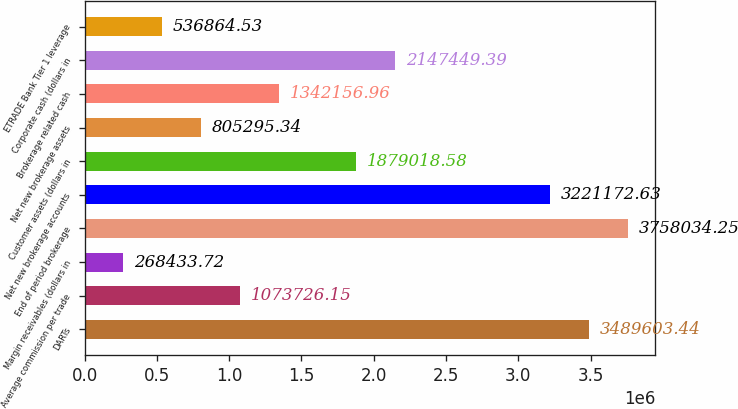<chart> <loc_0><loc_0><loc_500><loc_500><bar_chart><fcel>DARTs<fcel>Average commission per trade<fcel>Margin receivables (dollars in<fcel>End of period brokerage<fcel>Net new brokerage accounts<fcel>Customer assets (dollars in<fcel>Net new brokerage assets<fcel>Brokerage related cash<fcel>Corporate cash (dollars in<fcel>ETRADE Bank Tier 1 leverage<nl><fcel>3.4896e+06<fcel>1.07373e+06<fcel>268434<fcel>3.75803e+06<fcel>3.22117e+06<fcel>1.87902e+06<fcel>805295<fcel>1.34216e+06<fcel>2.14745e+06<fcel>536865<nl></chart> 